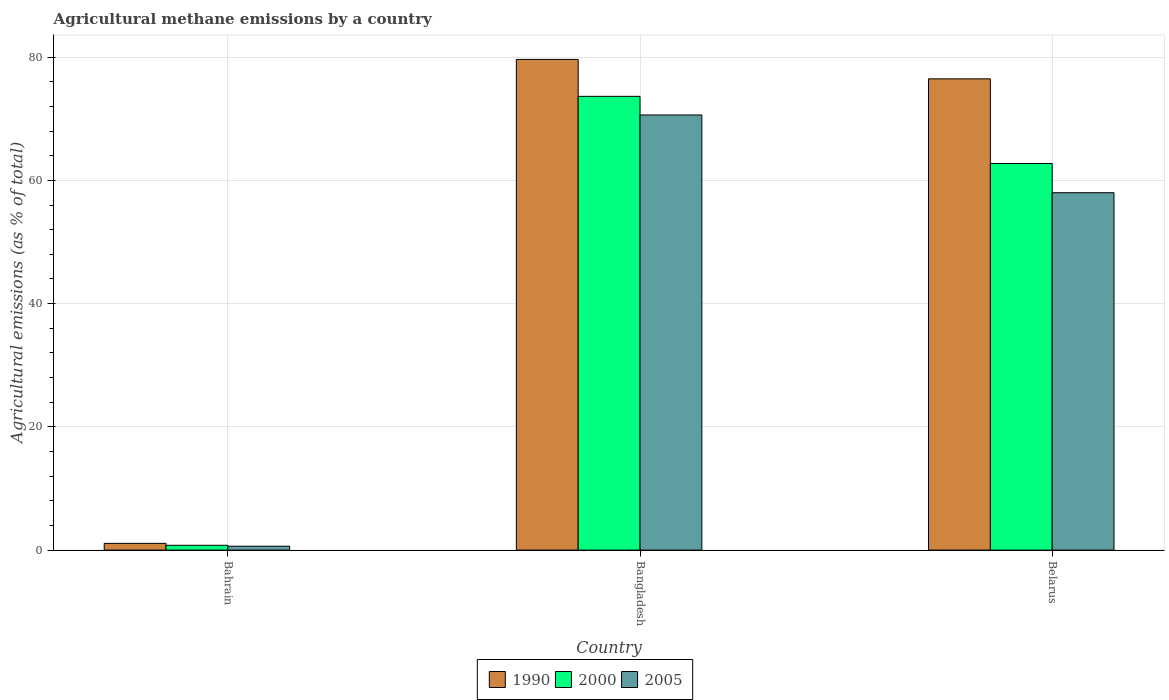How many groups of bars are there?
Give a very brief answer. 3. Are the number of bars on each tick of the X-axis equal?
Your response must be concise. Yes. How many bars are there on the 3rd tick from the left?
Ensure brevity in your answer.  3. What is the label of the 1st group of bars from the left?
Provide a succinct answer. Bahrain. What is the amount of agricultural methane emitted in 1990 in Bangladesh?
Your answer should be very brief. 79.64. Across all countries, what is the maximum amount of agricultural methane emitted in 2005?
Give a very brief answer. 70.62. Across all countries, what is the minimum amount of agricultural methane emitted in 2000?
Keep it short and to the point. 0.78. In which country was the amount of agricultural methane emitted in 2005 maximum?
Your response must be concise. Bangladesh. In which country was the amount of agricultural methane emitted in 2005 minimum?
Provide a short and direct response. Bahrain. What is the total amount of agricultural methane emitted in 2005 in the graph?
Keep it short and to the point. 129.26. What is the difference between the amount of agricultural methane emitted in 2005 in Bahrain and that in Belarus?
Offer a very short reply. -57.37. What is the difference between the amount of agricultural methane emitted in 1990 in Bangladesh and the amount of agricultural methane emitted in 2005 in Belarus?
Offer a very short reply. 21.63. What is the average amount of agricultural methane emitted in 2000 per country?
Offer a terse response. 45.72. What is the difference between the amount of agricultural methane emitted of/in 1990 and amount of agricultural methane emitted of/in 2000 in Bahrain?
Offer a very short reply. 0.31. What is the ratio of the amount of agricultural methane emitted in 2005 in Bahrain to that in Belarus?
Your answer should be very brief. 0.01. Is the difference between the amount of agricultural methane emitted in 1990 in Bangladesh and Belarus greater than the difference between the amount of agricultural methane emitted in 2000 in Bangladesh and Belarus?
Your response must be concise. No. What is the difference between the highest and the second highest amount of agricultural methane emitted in 1990?
Ensure brevity in your answer.  -75.4. What is the difference between the highest and the lowest amount of agricultural methane emitted in 1990?
Provide a short and direct response. 78.55. Is the sum of the amount of agricultural methane emitted in 2000 in Bahrain and Belarus greater than the maximum amount of agricultural methane emitted in 1990 across all countries?
Your response must be concise. No. What does the 2nd bar from the right in Belarus represents?
Offer a terse response. 2000. How many bars are there?
Your answer should be compact. 9. How many countries are there in the graph?
Your answer should be very brief. 3. What is the difference between two consecutive major ticks on the Y-axis?
Your response must be concise. 20. Does the graph contain any zero values?
Your answer should be compact. No. Where does the legend appear in the graph?
Your response must be concise. Bottom center. How are the legend labels stacked?
Provide a succinct answer. Horizontal. What is the title of the graph?
Offer a very short reply. Agricultural methane emissions by a country. Does "1960" appear as one of the legend labels in the graph?
Provide a short and direct response. No. What is the label or title of the X-axis?
Offer a very short reply. Country. What is the label or title of the Y-axis?
Provide a succinct answer. Agricultural emissions (as % of total). What is the Agricultural emissions (as % of total) of 1990 in Bahrain?
Provide a short and direct response. 1.09. What is the Agricultural emissions (as % of total) of 2000 in Bahrain?
Ensure brevity in your answer.  0.78. What is the Agricultural emissions (as % of total) of 2005 in Bahrain?
Your response must be concise. 0.63. What is the Agricultural emissions (as % of total) of 1990 in Bangladesh?
Make the answer very short. 79.64. What is the Agricultural emissions (as % of total) in 2000 in Bangladesh?
Ensure brevity in your answer.  73.64. What is the Agricultural emissions (as % of total) of 2005 in Bangladesh?
Ensure brevity in your answer.  70.62. What is the Agricultural emissions (as % of total) in 1990 in Belarus?
Your answer should be compact. 76.49. What is the Agricultural emissions (as % of total) in 2000 in Belarus?
Your answer should be compact. 62.75. What is the Agricultural emissions (as % of total) of 2005 in Belarus?
Provide a short and direct response. 58.01. Across all countries, what is the maximum Agricultural emissions (as % of total) in 1990?
Ensure brevity in your answer.  79.64. Across all countries, what is the maximum Agricultural emissions (as % of total) of 2000?
Offer a terse response. 73.64. Across all countries, what is the maximum Agricultural emissions (as % of total) in 2005?
Keep it short and to the point. 70.62. Across all countries, what is the minimum Agricultural emissions (as % of total) in 1990?
Provide a short and direct response. 1.09. Across all countries, what is the minimum Agricultural emissions (as % of total) of 2000?
Give a very brief answer. 0.78. Across all countries, what is the minimum Agricultural emissions (as % of total) in 2005?
Provide a short and direct response. 0.63. What is the total Agricultural emissions (as % of total) of 1990 in the graph?
Your answer should be compact. 157.22. What is the total Agricultural emissions (as % of total) of 2000 in the graph?
Provide a succinct answer. 137.17. What is the total Agricultural emissions (as % of total) in 2005 in the graph?
Your answer should be very brief. 129.26. What is the difference between the Agricultural emissions (as % of total) in 1990 in Bahrain and that in Bangladesh?
Your response must be concise. -78.55. What is the difference between the Agricultural emissions (as % of total) in 2000 in Bahrain and that in Bangladesh?
Offer a terse response. -72.86. What is the difference between the Agricultural emissions (as % of total) of 2005 in Bahrain and that in Bangladesh?
Provide a short and direct response. -69.99. What is the difference between the Agricultural emissions (as % of total) of 1990 in Bahrain and that in Belarus?
Keep it short and to the point. -75.4. What is the difference between the Agricultural emissions (as % of total) in 2000 in Bahrain and that in Belarus?
Offer a terse response. -61.97. What is the difference between the Agricultural emissions (as % of total) of 2005 in Bahrain and that in Belarus?
Your answer should be very brief. -57.37. What is the difference between the Agricultural emissions (as % of total) of 1990 in Bangladesh and that in Belarus?
Make the answer very short. 3.15. What is the difference between the Agricultural emissions (as % of total) of 2000 in Bangladesh and that in Belarus?
Offer a terse response. 10.89. What is the difference between the Agricultural emissions (as % of total) in 2005 in Bangladesh and that in Belarus?
Offer a very short reply. 12.62. What is the difference between the Agricultural emissions (as % of total) of 1990 in Bahrain and the Agricultural emissions (as % of total) of 2000 in Bangladesh?
Your response must be concise. -72.55. What is the difference between the Agricultural emissions (as % of total) in 1990 in Bahrain and the Agricultural emissions (as % of total) in 2005 in Bangladesh?
Your answer should be very brief. -69.53. What is the difference between the Agricultural emissions (as % of total) in 2000 in Bahrain and the Agricultural emissions (as % of total) in 2005 in Bangladesh?
Make the answer very short. -69.84. What is the difference between the Agricultural emissions (as % of total) in 1990 in Bahrain and the Agricultural emissions (as % of total) in 2000 in Belarus?
Offer a very short reply. -61.66. What is the difference between the Agricultural emissions (as % of total) in 1990 in Bahrain and the Agricultural emissions (as % of total) in 2005 in Belarus?
Your answer should be compact. -56.91. What is the difference between the Agricultural emissions (as % of total) of 2000 in Bahrain and the Agricultural emissions (as % of total) of 2005 in Belarus?
Provide a short and direct response. -57.22. What is the difference between the Agricultural emissions (as % of total) in 1990 in Bangladesh and the Agricultural emissions (as % of total) in 2000 in Belarus?
Make the answer very short. 16.89. What is the difference between the Agricultural emissions (as % of total) in 1990 in Bangladesh and the Agricultural emissions (as % of total) in 2005 in Belarus?
Your answer should be very brief. 21.63. What is the difference between the Agricultural emissions (as % of total) in 2000 in Bangladesh and the Agricultural emissions (as % of total) in 2005 in Belarus?
Provide a short and direct response. 15.64. What is the average Agricultural emissions (as % of total) of 1990 per country?
Ensure brevity in your answer.  52.41. What is the average Agricultural emissions (as % of total) in 2000 per country?
Provide a short and direct response. 45.72. What is the average Agricultural emissions (as % of total) in 2005 per country?
Your response must be concise. 43.09. What is the difference between the Agricultural emissions (as % of total) of 1990 and Agricultural emissions (as % of total) of 2000 in Bahrain?
Offer a terse response. 0.31. What is the difference between the Agricultural emissions (as % of total) of 1990 and Agricultural emissions (as % of total) of 2005 in Bahrain?
Make the answer very short. 0.46. What is the difference between the Agricultural emissions (as % of total) of 2000 and Agricultural emissions (as % of total) of 2005 in Bahrain?
Provide a succinct answer. 0.15. What is the difference between the Agricultural emissions (as % of total) of 1990 and Agricultural emissions (as % of total) of 2000 in Bangladesh?
Offer a terse response. 6. What is the difference between the Agricultural emissions (as % of total) of 1990 and Agricultural emissions (as % of total) of 2005 in Bangladesh?
Your answer should be very brief. 9.02. What is the difference between the Agricultural emissions (as % of total) of 2000 and Agricultural emissions (as % of total) of 2005 in Bangladesh?
Offer a terse response. 3.02. What is the difference between the Agricultural emissions (as % of total) of 1990 and Agricultural emissions (as % of total) of 2000 in Belarus?
Provide a succinct answer. 13.74. What is the difference between the Agricultural emissions (as % of total) in 1990 and Agricultural emissions (as % of total) in 2005 in Belarus?
Your answer should be compact. 18.48. What is the difference between the Agricultural emissions (as % of total) of 2000 and Agricultural emissions (as % of total) of 2005 in Belarus?
Keep it short and to the point. 4.74. What is the ratio of the Agricultural emissions (as % of total) of 1990 in Bahrain to that in Bangladesh?
Offer a terse response. 0.01. What is the ratio of the Agricultural emissions (as % of total) in 2000 in Bahrain to that in Bangladesh?
Give a very brief answer. 0.01. What is the ratio of the Agricultural emissions (as % of total) of 2005 in Bahrain to that in Bangladesh?
Your answer should be very brief. 0.01. What is the ratio of the Agricultural emissions (as % of total) of 1990 in Bahrain to that in Belarus?
Keep it short and to the point. 0.01. What is the ratio of the Agricultural emissions (as % of total) in 2000 in Bahrain to that in Belarus?
Ensure brevity in your answer.  0.01. What is the ratio of the Agricultural emissions (as % of total) in 2005 in Bahrain to that in Belarus?
Ensure brevity in your answer.  0.01. What is the ratio of the Agricultural emissions (as % of total) of 1990 in Bangladesh to that in Belarus?
Provide a succinct answer. 1.04. What is the ratio of the Agricultural emissions (as % of total) in 2000 in Bangladesh to that in Belarus?
Your response must be concise. 1.17. What is the ratio of the Agricultural emissions (as % of total) in 2005 in Bangladesh to that in Belarus?
Offer a terse response. 1.22. What is the difference between the highest and the second highest Agricultural emissions (as % of total) of 1990?
Your answer should be very brief. 3.15. What is the difference between the highest and the second highest Agricultural emissions (as % of total) in 2000?
Provide a succinct answer. 10.89. What is the difference between the highest and the second highest Agricultural emissions (as % of total) in 2005?
Provide a short and direct response. 12.62. What is the difference between the highest and the lowest Agricultural emissions (as % of total) in 1990?
Offer a terse response. 78.55. What is the difference between the highest and the lowest Agricultural emissions (as % of total) of 2000?
Provide a succinct answer. 72.86. What is the difference between the highest and the lowest Agricultural emissions (as % of total) in 2005?
Offer a terse response. 69.99. 